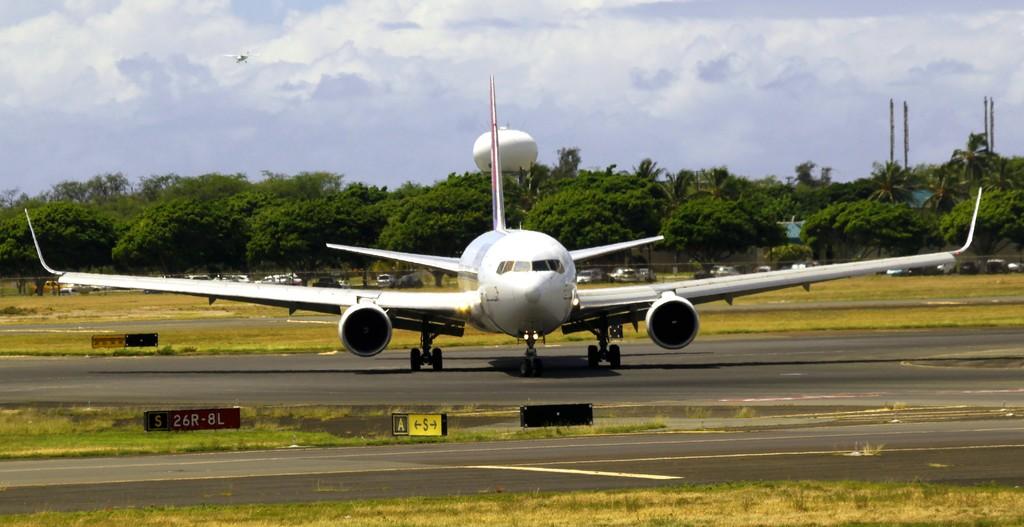What does the red sign say?
Your answer should be compact. Unanswerable. 